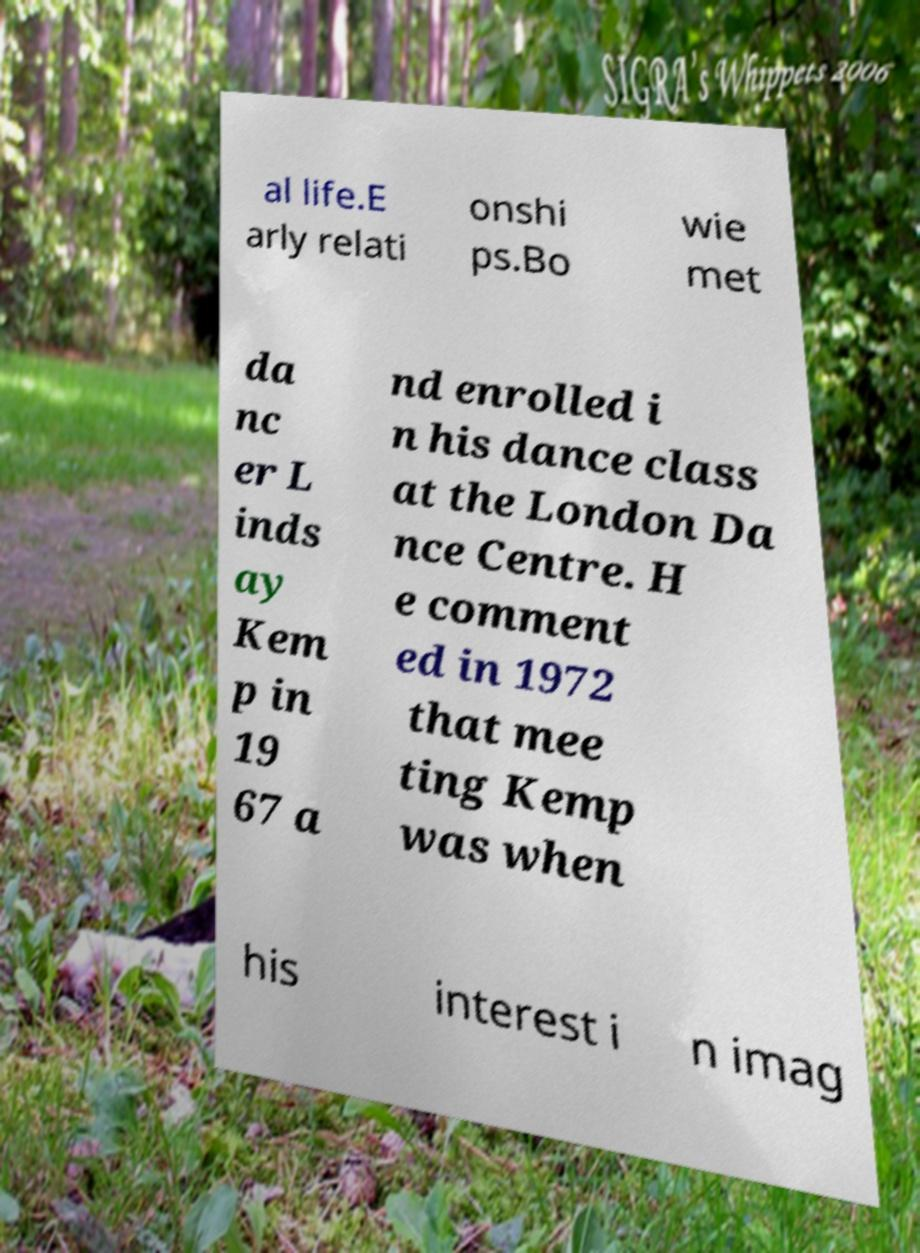What messages or text are displayed in this image? I need them in a readable, typed format. al life.E arly relati onshi ps.Bo wie met da nc er L inds ay Kem p in 19 67 a nd enrolled i n his dance class at the London Da nce Centre. H e comment ed in 1972 that mee ting Kemp was when his interest i n imag 